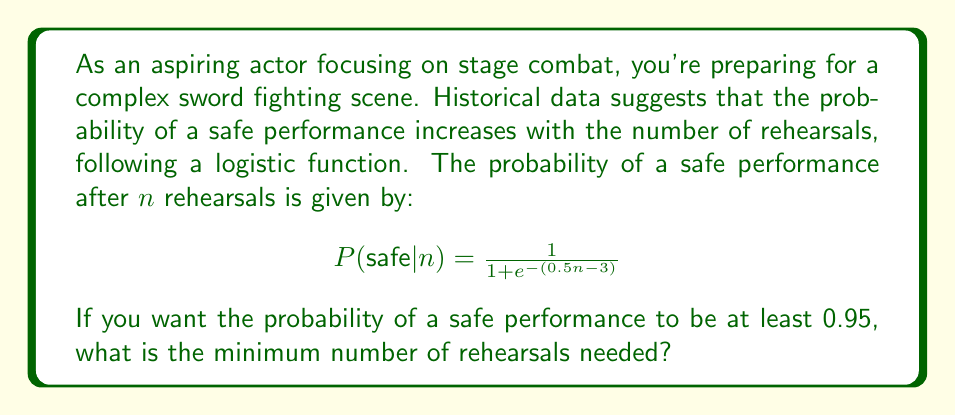Can you answer this question? To solve this problem, we need to use the given logistic function and determine the value of $n$ that results in a probability of at least 0.95. Let's approach this step-by-step:

1) We want to find $n$ such that:

   $$\frac{1}{1 + e^{-(0.5n - 3)}} \geq 0.95$$

2) Let's solve this inequality:

   $$\frac{1}{1 + e^{-(0.5n - 3)}} \geq 0.95$$
   $$1 + e^{-(0.5n - 3)} \leq \frac{1}{0.95}$$
   $$e^{-(0.5n - 3)} \leq \frac{1}{0.95} - 1 \approx 0.0526$$

3) Taking the natural log of both sides:

   $$-(0.5n - 3) \leq \ln(0.0526)$$
   $$0.5n - 3 \geq -\ln(0.0526)$$
   $$0.5n \geq -\ln(0.0526) + 3$$
   $$n \geq \frac{-\ln(0.0526) + 3}{0.5}$$

4) Calculating the right-hand side:

   $$n \geq \frac{2.9444 + 3}{0.5} = 11.8888$$

5) Since $n$ must be a whole number (we can't have a fractional number of rehearsals), we need to round up to the nearest integer.
Answer: The minimum number of rehearsals needed is 12. 